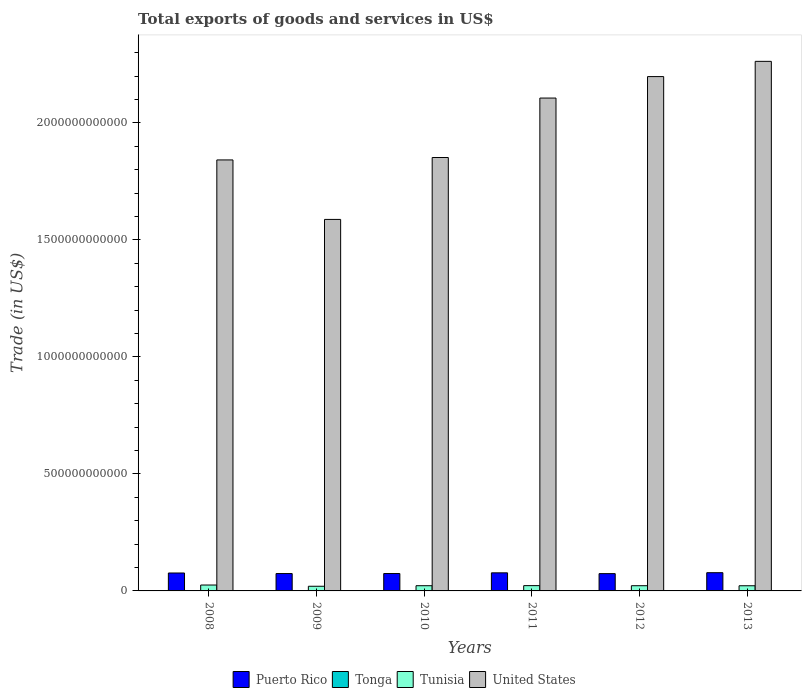Are the number of bars on each tick of the X-axis equal?
Make the answer very short. Yes. What is the label of the 1st group of bars from the left?
Offer a terse response. 2008. In how many cases, is the number of bars for a given year not equal to the number of legend labels?
Offer a very short reply. 0. What is the total exports of goods and services in Puerto Rico in 2008?
Provide a succinct answer. 7.66e+1. Across all years, what is the maximum total exports of goods and services in Tonga?
Your answer should be very brief. 9.16e+07. Across all years, what is the minimum total exports of goods and services in United States?
Offer a terse response. 1.59e+12. In which year was the total exports of goods and services in Puerto Rico maximum?
Offer a very short reply. 2013. In which year was the total exports of goods and services in Tonga minimum?
Your response must be concise. 2009. What is the total total exports of goods and services in Tunisia in the graph?
Offer a terse response. 1.34e+11. What is the difference between the total exports of goods and services in Tonga in 2008 and that in 2009?
Your answer should be compact. 7.40e+05. What is the difference between the total exports of goods and services in Puerto Rico in 2008 and the total exports of goods and services in Tunisia in 2013?
Provide a short and direct response. 5.45e+1. What is the average total exports of goods and services in Tonga per year?
Ensure brevity in your answer.  6.58e+07. In the year 2009, what is the difference between the total exports of goods and services in United States and total exports of goods and services in Tonga?
Ensure brevity in your answer.  1.59e+12. What is the ratio of the total exports of goods and services in Puerto Rico in 2008 to that in 2010?
Your response must be concise. 1.03. Is the total exports of goods and services in Puerto Rico in 2011 less than that in 2012?
Keep it short and to the point. No. What is the difference between the highest and the second highest total exports of goods and services in Puerto Rico?
Keep it short and to the point. 6.43e+08. What is the difference between the highest and the lowest total exports of goods and services in Tunisia?
Make the answer very short. 5.28e+09. In how many years, is the total exports of goods and services in Puerto Rico greater than the average total exports of goods and services in Puerto Rico taken over all years?
Provide a short and direct response. 3. Is it the case that in every year, the sum of the total exports of goods and services in Tonga and total exports of goods and services in Puerto Rico is greater than the sum of total exports of goods and services in Tunisia and total exports of goods and services in United States?
Offer a very short reply. Yes. What does the 1st bar from the left in 2012 represents?
Make the answer very short. Puerto Rico. What does the 2nd bar from the right in 2013 represents?
Give a very brief answer. Tunisia. Is it the case that in every year, the sum of the total exports of goods and services in Tunisia and total exports of goods and services in Puerto Rico is greater than the total exports of goods and services in United States?
Make the answer very short. No. What is the difference between two consecutive major ticks on the Y-axis?
Your response must be concise. 5.00e+11. Are the values on the major ticks of Y-axis written in scientific E-notation?
Ensure brevity in your answer.  No. Where does the legend appear in the graph?
Offer a very short reply. Bottom center. How many legend labels are there?
Your response must be concise. 4. What is the title of the graph?
Your response must be concise. Total exports of goods and services in US$. Does "Faeroe Islands" appear as one of the legend labels in the graph?
Make the answer very short. No. What is the label or title of the X-axis?
Offer a terse response. Years. What is the label or title of the Y-axis?
Provide a succinct answer. Trade (in US$). What is the Trade (in US$) in Puerto Rico in 2008?
Make the answer very short. 7.66e+1. What is the Trade (in US$) of Tonga in 2008?
Make the answer very short. 4.65e+07. What is the Trade (in US$) of Tunisia in 2008?
Make the answer very short. 2.52e+1. What is the Trade (in US$) of United States in 2008?
Make the answer very short. 1.84e+12. What is the Trade (in US$) of Puerto Rico in 2009?
Make the answer very short. 7.42e+1. What is the Trade (in US$) in Tonga in 2009?
Offer a terse response. 4.58e+07. What is the Trade (in US$) in Tunisia in 2009?
Offer a terse response. 1.99e+1. What is the Trade (in US$) in United States in 2009?
Provide a short and direct response. 1.59e+12. What is the Trade (in US$) of Puerto Rico in 2010?
Your answer should be compact. 7.43e+1. What is the Trade (in US$) in Tonga in 2010?
Offer a terse response. 4.72e+07. What is the Trade (in US$) of Tunisia in 2010?
Keep it short and to the point. 2.22e+1. What is the Trade (in US$) of United States in 2010?
Make the answer very short. 1.85e+12. What is the Trade (in US$) in Puerto Rico in 2011?
Make the answer very short. 7.73e+1. What is the Trade (in US$) of Tonga in 2011?
Your response must be concise. 7.43e+07. What is the Trade (in US$) in Tunisia in 2011?
Give a very brief answer. 2.26e+1. What is the Trade (in US$) in United States in 2011?
Your answer should be compact. 2.11e+12. What is the Trade (in US$) in Puerto Rico in 2012?
Offer a terse response. 7.39e+1. What is the Trade (in US$) in Tonga in 2012?
Your answer should be compact. 8.93e+07. What is the Trade (in US$) of Tunisia in 2012?
Make the answer very short. 2.23e+1. What is the Trade (in US$) of United States in 2012?
Provide a short and direct response. 2.20e+12. What is the Trade (in US$) in Puerto Rico in 2013?
Your answer should be compact. 7.79e+1. What is the Trade (in US$) in Tonga in 2013?
Your answer should be very brief. 9.16e+07. What is the Trade (in US$) of Tunisia in 2013?
Provide a succinct answer. 2.21e+1. What is the Trade (in US$) in United States in 2013?
Offer a terse response. 2.26e+12. Across all years, what is the maximum Trade (in US$) of Puerto Rico?
Your answer should be very brief. 7.79e+1. Across all years, what is the maximum Trade (in US$) of Tonga?
Your response must be concise. 9.16e+07. Across all years, what is the maximum Trade (in US$) of Tunisia?
Your answer should be very brief. 2.52e+1. Across all years, what is the maximum Trade (in US$) in United States?
Offer a very short reply. 2.26e+12. Across all years, what is the minimum Trade (in US$) of Puerto Rico?
Give a very brief answer. 7.39e+1. Across all years, what is the minimum Trade (in US$) in Tonga?
Provide a succinct answer. 4.58e+07. Across all years, what is the minimum Trade (in US$) in Tunisia?
Ensure brevity in your answer.  1.99e+1. Across all years, what is the minimum Trade (in US$) in United States?
Your answer should be very brief. 1.59e+12. What is the total Trade (in US$) in Puerto Rico in the graph?
Give a very brief answer. 4.54e+11. What is the total Trade (in US$) of Tonga in the graph?
Keep it short and to the point. 3.95e+08. What is the total Trade (in US$) of Tunisia in the graph?
Your response must be concise. 1.34e+11. What is the total Trade (in US$) of United States in the graph?
Keep it short and to the point. 1.18e+13. What is the difference between the Trade (in US$) of Puerto Rico in 2008 and that in 2009?
Keep it short and to the point. 2.40e+09. What is the difference between the Trade (in US$) of Tonga in 2008 and that in 2009?
Keep it short and to the point. 7.40e+05. What is the difference between the Trade (in US$) of Tunisia in 2008 and that in 2009?
Make the answer very short. 5.28e+09. What is the difference between the Trade (in US$) of United States in 2008 and that in 2009?
Your answer should be very brief. 2.54e+11. What is the difference between the Trade (in US$) of Puerto Rico in 2008 and that in 2010?
Ensure brevity in your answer.  2.30e+09. What is the difference between the Trade (in US$) in Tonga in 2008 and that in 2010?
Your response must be concise. -6.13e+05. What is the difference between the Trade (in US$) in Tunisia in 2008 and that in 2010?
Offer a very short reply. 2.96e+09. What is the difference between the Trade (in US$) of United States in 2008 and that in 2010?
Offer a very short reply. -1.04e+1. What is the difference between the Trade (in US$) of Puerto Rico in 2008 and that in 2011?
Ensure brevity in your answer.  -6.60e+08. What is the difference between the Trade (in US$) in Tonga in 2008 and that in 2011?
Provide a short and direct response. -2.78e+07. What is the difference between the Trade (in US$) in Tunisia in 2008 and that in 2011?
Offer a very short reply. 2.60e+09. What is the difference between the Trade (in US$) in United States in 2008 and that in 2011?
Offer a very short reply. -2.64e+11. What is the difference between the Trade (in US$) in Puerto Rico in 2008 and that in 2012?
Your answer should be very brief. 2.70e+09. What is the difference between the Trade (in US$) in Tonga in 2008 and that in 2012?
Keep it short and to the point. -4.27e+07. What is the difference between the Trade (in US$) of Tunisia in 2008 and that in 2012?
Your answer should be very brief. 2.95e+09. What is the difference between the Trade (in US$) of United States in 2008 and that in 2012?
Provide a succinct answer. -3.56e+11. What is the difference between the Trade (in US$) of Puerto Rico in 2008 and that in 2013?
Make the answer very short. -1.30e+09. What is the difference between the Trade (in US$) in Tonga in 2008 and that in 2013?
Ensure brevity in your answer.  -4.51e+07. What is the difference between the Trade (in US$) of Tunisia in 2008 and that in 2013?
Your response must be concise. 3.12e+09. What is the difference between the Trade (in US$) in United States in 2008 and that in 2013?
Your answer should be very brief. -4.21e+11. What is the difference between the Trade (in US$) in Puerto Rico in 2009 and that in 2010?
Offer a terse response. -9.71e+07. What is the difference between the Trade (in US$) in Tonga in 2009 and that in 2010?
Ensure brevity in your answer.  -1.35e+06. What is the difference between the Trade (in US$) of Tunisia in 2009 and that in 2010?
Ensure brevity in your answer.  -2.32e+09. What is the difference between the Trade (in US$) of United States in 2009 and that in 2010?
Your answer should be very brief. -2.65e+11. What is the difference between the Trade (in US$) in Puerto Rico in 2009 and that in 2011?
Offer a terse response. -3.06e+09. What is the difference between the Trade (in US$) in Tonga in 2009 and that in 2011?
Your answer should be compact. -2.85e+07. What is the difference between the Trade (in US$) in Tunisia in 2009 and that in 2011?
Provide a succinct answer. -2.69e+09. What is the difference between the Trade (in US$) of United States in 2009 and that in 2011?
Keep it short and to the point. -5.19e+11. What is the difference between the Trade (in US$) of Puerto Rico in 2009 and that in 2012?
Your response must be concise. 3.04e+08. What is the difference between the Trade (in US$) of Tonga in 2009 and that in 2012?
Provide a succinct answer. -4.35e+07. What is the difference between the Trade (in US$) of Tunisia in 2009 and that in 2012?
Your answer should be compact. -2.33e+09. What is the difference between the Trade (in US$) in United States in 2009 and that in 2012?
Make the answer very short. -6.10e+11. What is the difference between the Trade (in US$) in Puerto Rico in 2009 and that in 2013?
Give a very brief answer. -3.70e+09. What is the difference between the Trade (in US$) of Tonga in 2009 and that in 2013?
Provide a short and direct response. -4.58e+07. What is the difference between the Trade (in US$) of Tunisia in 2009 and that in 2013?
Ensure brevity in your answer.  -2.17e+09. What is the difference between the Trade (in US$) in United States in 2009 and that in 2013?
Offer a very short reply. -6.76e+11. What is the difference between the Trade (in US$) of Puerto Rico in 2010 and that in 2011?
Keep it short and to the point. -2.96e+09. What is the difference between the Trade (in US$) in Tonga in 2010 and that in 2011?
Offer a terse response. -2.72e+07. What is the difference between the Trade (in US$) in Tunisia in 2010 and that in 2011?
Your answer should be very brief. -3.66e+08. What is the difference between the Trade (in US$) of United States in 2010 and that in 2011?
Ensure brevity in your answer.  -2.54e+11. What is the difference between the Trade (in US$) of Puerto Rico in 2010 and that in 2012?
Your answer should be very brief. 4.01e+08. What is the difference between the Trade (in US$) in Tonga in 2010 and that in 2012?
Provide a succinct answer. -4.21e+07. What is the difference between the Trade (in US$) of Tunisia in 2010 and that in 2012?
Provide a succinct answer. -1.40e+07. What is the difference between the Trade (in US$) of United States in 2010 and that in 2012?
Ensure brevity in your answer.  -3.46e+11. What is the difference between the Trade (in US$) of Puerto Rico in 2010 and that in 2013?
Make the answer very short. -3.61e+09. What is the difference between the Trade (in US$) in Tonga in 2010 and that in 2013?
Make the answer very short. -4.45e+07. What is the difference between the Trade (in US$) of Tunisia in 2010 and that in 2013?
Ensure brevity in your answer.  1.54e+08. What is the difference between the Trade (in US$) of United States in 2010 and that in 2013?
Your answer should be very brief. -4.11e+11. What is the difference between the Trade (in US$) of Puerto Rico in 2011 and that in 2012?
Your answer should be compact. 3.36e+09. What is the difference between the Trade (in US$) in Tonga in 2011 and that in 2012?
Provide a succinct answer. -1.49e+07. What is the difference between the Trade (in US$) of Tunisia in 2011 and that in 2012?
Make the answer very short. 3.52e+08. What is the difference between the Trade (in US$) of United States in 2011 and that in 2012?
Ensure brevity in your answer.  -9.18e+1. What is the difference between the Trade (in US$) of Puerto Rico in 2011 and that in 2013?
Make the answer very short. -6.43e+08. What is the difference between the Trade (in US$) of Tonga in 2011 and that in 2013?
Your answer should be very brief. -1.73e+07. What is the difference between the Trade (in US$) in Tunisia in 2011 and that in 2013?
Provide a succinct answer. 5.20e+08. What is the difference between the Trade (in US$) of United States in 2011 and that in 2013?
Offer a very short reply. -1.57e+11. What is the difference between the Trade (in US$) in Puerto Rico in 2012 and that in 2013?
Give a very brief answer. -4.01e+09. What is the difference between the Trade (in US$) in Tonga in 2012 and that in 2013?
Provide a short and direct response. -2.35e+06. What is the difference between the Trade (in US$) in Tunisia in 2012 and that in 2013?
Offer a very short reply. 1.68e+08. What is the difference between the Trade (in US$) in United States in 2012 and that in 2013?
Your answer should be very brief. -6.51e+1. What is the difference between the Trade (in US$) of Puerto Rico in 2008 and the Trade (in US$) of Tonga in 2009?
Keep it short and to the point. 7.66e+1. What is the difference between the Trade (in US$) in Puerto Rico in 2008 and the Trade (in US$) in Tunisia in 2009?
Offer a terse response. 5.67e+1. What is the difference between the Trade (in US$) in Puerto Rico in 2008 and the Trade (in US$) in United States in 2009?
Make the answer very short. -1.51e+12. What is the difference between the Trade (in US$) in Tonga in 2008 and the Trade (in US$) in Tunisia in 2009?
Offer a very short reply. -1.99e+1. What is the difference between the Trade (in US$) of Tonga in 2008 and the Trade (in US$) of United States in 2009?
Ensure brevity in your answer.  -1.59e+12. What is the difference between the Trade (in US$) of Tunisia in 2008 and the Trade (in US$) of United States in 2009?
Provide a short and direct response. -1.56e+12. What is the difference between the Trade (in US$) in Puerto Rico in 2008 and the Trade (in US$) in Tonga in 2010?
Give a very brief answer. 7.66e+1. What is the difference between the Trade (in US$) of Puerto Rico in 2008 and the Trade (in US$) of Tunisia in 2010?
Make the answer very short. 5.44e+1. What is the difference between the Trade (in US$) of Puerto Rico in 2008 and the Trade (in US$) of United States in 2010?
Your answer should be compact. -1.78e+12. What is the difference between the Trade (in US$) in Tonga in 2008 and the Trade (in US$) in Tunisia in 2010?
Provide a succinct answer. -2.22e+1. What is the difference between the Trade (in US$) of Tonga in 2008 and the Trade (in US$) of United States in 2010?
Offer a terse response. -1.85e+12. What is the difference between the Trade (in US$) in Tunisia in 2008 and the Trade (in US$) in United States in 2010?
Your response must be concise. -1.83e+12. What is the difference between the Trade (in US$) of Puerto Rico in 2008 and the Trade (in US$) of Tonga in 2011?
Offer a terse response. 7.65e+1. What is the difference between the Trade (in US$) in Puerto Rico in 2008 and the Trade (in US$) in Tunisia in 2011?
Your answer should be compact. 5.40e+1. What is the difference between the Trade (in US$) of Puerto Rico in 2008 and the Trade (in US$) of United States in 2011?
Give a very brief answer. -2.03e+12. What is the difference between the Trade (in US$) of Tonga in 2008 and the Trade (in US$) of Tunisia in 2011?
Offer a very short reply. -2.26e+1. What is the difference between the Trade (in US$) in Tonga in 2008 and the Trade (in US$) in United States in 2011?
Give a very brief answer. -2.11e+12. What is the difference between the Trade (in US$) of Tunisia in 2008 and the Trade (in US$) of United States in 2011?
Make the answer very short. -2.08e+12. What is the difference between the Trade (in US$) in Puerto Rico in 2008 and the Trade (in US$) in Tonga in 2012?
Give a very brief answer. 7.65e+1. What is the difference between the Trade (in US$) of Puerto Rico in 2008 and the Trade (in US$) of Tunisia in 2012?
Offer a terse response. 5.44e+1. What is the difference between the Trade (in US$) in Puerto Rico in 2008 and the Trade (in US$) in United States in 2012?
Give a very brief answer. -2.12e+12. What is the difference between the Trade (in US$) of Tonga in 2008 and the Trade (in US$) of Tunisia in 2012?
Keep it short and to the point. -2.22e+1. What is the difference between the Trade (in US$) of Tonga in 2008 and the Trade (in US$) of United States in 2012?
Your answer should be very brief. -2.20e+12. What is the difference between the Trade (in US$) of Tunisia in 2008 and the Trade (in US$) of United States in 2012?
Ensure brevity in your answer.  -2.17e+12. What is the difference between the Trade (in US$) of Puerto Rico in 2008 and the Trade (in US$) of Tonga in 2013?
Offer a very short reply. 7.65e+1. What is the difference between the Trade (in US$) in Puerto Rico in 2008 and the Trade (in US$) in Tunisia in 2013?
Make the answer very short. 5.45e+1. What is the difference between the Trade (in US$) in Puerto Rico in 2008 and the Trade (in US$) in United States in 2013?
Make the answer very short. -2.19e+12. What is the difference between the Trade (in US$) in Tonga in 2008 and the Trade (in US$) in Tunisia in 2013?
Provide a succinct answer. -2.20e+1. What is the difference between the Trade (in US$) of Tonga in 2008 and the Trade (in US$) of United States in 2013?
Offer a very short reply. -2.26e+12. What is the difference between the Trade (in US$) in Tunisia in 2008 and the Trade (in US$) in United States in 2013?
Offer a very short reply. -2.24e+12. What is the difference between the Trade (in US$) in Puerto Rico in 2009 and the Trade (in US$) in Tonga in 2010?
Your answer should be compact. 7.42e+1. What is the difference between the Trade (in US$) in Puerto Rico in 2009 and the Trade (in US$) in Tunisia in 2010?
Your answer should be compact. 5.20e+1. What is the difference between the Trade (in US$) in Puerto Rico in 2009 and the Trade (in US$) in United States in 2010?
Provide a short and direct response. -1.78e+12. What is the difference between the Trade (in US$) in Tonga in 2009 and the Trade (in US$) in Tunisia in 2010?
Offer a very short reply. -2.22e+1. What is the difference between the Trade (in US$) of Tonga in 2009 and the Trade (in US$) of United States in 2010?
Ensure brevity in your answer.  -1.85e+12. What is the difference between the Trade (in US$) of Tunisia in 2009 and the Trade (in US$) of United States in 2010?
Provide a succinct answer. -1.83e+12. What is the difference between the Trade (in US$) of Puerto Rico in 2009 and the Trade (in US$) of Tonga in 2011?
Offer a terse response. 7.41e+1. What is the difference between the Trade (in US$) in Puerto Rico in 2009 and the Trade (in US$) in Tunisia in 2011?
Give a very brief answer. 5.16e+1. What is the difference between the Trade (in US$) of Puerto Rico in 2009 and the Trade (in US$) of United States in 2011?
Your answer should be very brief. -2.03e+12. What is the difference between the Trade (in US$) in Tonga in 2009 and the Trade (in US$) in Tunisia in 2011?
Ensure brevity in your answer.  -2.26e+1. What is the difference between the Trade (in US$) of Tonga in 2009 and the Trade (in US$) of United States in 2011?
Offer a very short reply. -2.11e+12. What is the difference between the Trade (in US$) in Tunisia in 2009 and the Trade (in US$) in United States in 2011?
Offer a terse response. -2.09e+12. What is the difference between the Trade (in US$) of Puerto Rico in 2009 and the Trade (in US$) of Tonga in 2012?
Provide a succinct answer. 7.41e+1. What is the difference between the Trade (in US$) of Puerto Rico in 2009 and the Trade (in US$) of Tunisia in 2012?
Ensure brevity in your answer.  5.20e+1. What is the difference between the Trade (in US$) of Puerto Rico in 2009 and the Trade (in US$) of United States in 2012?
Give a very brief answer. -2.12e+12. What is the difference between the Trade (in US$) in Tonga in 2009 and the Trade (in US$) in Tunisia in 2012?
Your answer should be compact. -2.22e+1. What is the difference between the Trade (in US$) of Tonga in 2009 and the Trade (in US$) of United States in 2012?
Provide a succinct answer. -2.20e+12. What is the difference between the Trade (in US$) of Tunisia in 2009 and the Trade (in US$) of United States in 2012?
Your answer should be very brief. -2.18e+12. What is the difference between the Trade (in US$) of Puerto Rico in 2009 and the Trade (in US$) of Tonga in 2013?
Offer a very short reply. 7.41e+1. What is the difference between the Trade (in US$) in Puerto Rico in 2009 and the Trade (in US$) in Tunisia in 2013?
Your answer should be compact. 5.21e+1. What is the difference between the Trade (in US$) in Puerto Rico in 2009 and the Trade (in US$) in United States in 2013?
Provide a short and direct response. -2.19e+12. What is the difference between the Trade (in US$) of Tonga in 2009 and the Trade (in US$) of Tunisia in 2013?
Provide a short and direct response. -2.20e+1. What is the difference between the Trade (in US$) of Tonga in 2009 and the Trade (in US$) of United States in 2013?
Offer a terse response. -2.26e+12. What is the difference between the Trade (in US$) in Tunisia in 2009 and the Trade (in US$) in United States in 2013?
Your response must be concise. -2.24e+12. What is the difference between the Trade (in US$) of Puerto Rico in 2010 and the Trade (in US$) of Tonga in 2011?
Provide a short and direct response. 7.42e+1. What is the difference between the Trade (in US$) in Puerto Rico in 2010 and the Trade (in US$) in Tunisia in 2011?
Make the answer very short. 5.17e+1. What is the difference between the Trade (in US$) in Puerto Rico in 2010 and the Trade (in US$) in United States in 2011?
Your answer should be compact. -2.03e+12. What is the difference between the Trade (in US$) of Tonga in 2010 and the Trade (in US$) of Tunisia in 2011?
Give a very brief answer. -2.26e+1. What is the difference between the Trade (in US$) of Tonga in 2010 and the Trade (in US$) of United States in 2011?
Your response must be concise. -2.11e+12. What is the difference between the Trade (in US$) of Tunisia in 2010 and the Trade (in US$) of United States in 2011?
Provide a short and direct response. -2.08e+12. What is the difference between the Trade (in US$) of Puerto Rico in 2010 and the Trade (in US$) of Tonga in 2012?
Your response must be concise. 7.42e+1. What is the difference between the Trade (in US$) in Puerto Rico in 2010 and the Trade (in US$) in Tunisia in 2012?
Your answer should be very brief. 5.21e+1. What is the difference between the Trade (in US$) in Puerto Rico in 2010 and the Trade (in US$) in United States in 2012?
Your answer should be compact. -2.12e+12. What is the difference between the Trade (in US$) in Tonga in 2010 and the Trade (in US$) in Tunisia in 2012?
Make the answer very short. -2.22e+1. What is the difference between the Trade (in US$) in Tonga in 2010 and the Trade (in US$) in United States in 2012?
Provide a succinct answer. -2.20e+12. What is the difference between the Trade (in US$) of Tunisia in 2010 and the Trade (in US$) of United States in 2012?
Keep it short and to the point. -2.18e+12. What is the difference between the Trade (in US$) of Puerto Rico in 2010 and the Trade (in US$) of Tonga in 2013?
Keep it short and to the point. 7.42e+1. What is the difference between the Trade (in US$) in Puerto Rico in 2010 and the Trade (in US$) in Tunisia in 2013?
Give a very brief answer. 5.22e+1. What is the difference between the Trade (in US$) of Puerto Rico in 2010 and the Trade (in US$) of United States in 2013?
Provide a short and direct response. -2.19e+12. What is the difference between the Trade (in US$) in Tonga in 2010 and the Trade (in US$) in Tunisia in 2013?
Offer a very short reply. -2.20e+1. What is the difference between the Trade (in US$) of Tonga in 2010 and the Trade (in US$) of United States in 2013?
Your response must be concise. -2.26e+12. What is the difference between the Trade (in US$) in Tunisia in 2010 and the Trade (in US$) in United States in 2013?
Your answer should be compact. -2.24e+12. What is the difference between the Trade (in US$) in Puerto Rico in 2011 and the Trade (in US$) in Tonga in 2012?
Make the answer very short. 7.72e+1. What is the difference between the Trade (in US$) in Puerto Rico in 2011 and the Trade (in US$) in Tunisia in 2012?
Ensure brevity in your answer.  5.50e+1. What is the difference between the Trade (in US$) in Puerto Rico in 2011 and the Trade (in US$) in United States in 2012?
Provide a short and direct response. -2.12e+12. What is the difference between the Trade (in US$) of Tonga in 2011 and the Trade (in US$) of Tunisia in 2012?
Give a very brief answer. -2.22e+1. What is the difference between the Trade (in US$) in Tonga in 2011 and the Trade (in US$) in United States in 2012?
Offer a terse response. -2.20e+12. What is the difference between the Trade (in US$) of Tunisia in 2011 and the Trade (in US$) of United States in 2012?
Provide a short and direct response. -2.18e+12. What is the difference between the Trade (in US$) of Puerto Rico in 2011 and the Trade (in US$) of Tonga in 2013?
Your answer should be compact. 7.72e+1. What is the difference between the Trade (in US$) of Puerto Rico in 2011 and the Trade (in US$) of Tunisia in 2013?
Offer a terse response. 5.52e+1. What is the difference between the Trade (in US$) of Puerto Rico in 2011 and the Trade (in US$) of United States in 2013?
Keep it short and to the point. -2.19e+12. What is the difference between the Trade (in US$) in Tonga in 2011 and the Trade (in US$) in Tunisia in 2013?
Your response must be concise. -2.20e+1. What is the difference between the Trade (in US$) of Tonga in 2011 and the Trade (in US$) of United States in 2013?
Ensure brevity in your answer.  -2.26e+12. What is the difference between the Trade (in US$) of Tunisia in 2011 and the Trade (in US$) of United States in 2013?
Give a very brief answer. -2.24e+12. What is the difference between the Trade (in US$) in Puerto Rico in 2012 and the Trade (in US$) in Tonga in 2013?
Provide a short and direct response. 7.38e+1. What is the difference between the Trade (in US$) in Puerto Rico in 2012 and the Trade (in US$) in Tunisia in 2013?
Offer a terse response. 5.18e+1. What is the difference between the Trade (in US$) in Puerto Rico in 2012 and the Trade (in US$) in United States in 2013?
Make the answer very short. -2.19e+12. What is the difference between the Trade (in US$) of Tonga in 2012 and the Trade (in US$) of Tunisia in 2013?
Make the answer very short. -2.20e+1. What is the difference between the Trade (in US$) in Tonga in 2012 and the Trade (in US$) in United States in 2013?
Provide a short and direct response. -2.26e+12. What is the difference between the Trade (in US$) in Tunisia in 2012 and the Trade (in US$) in United States in 2013?
Provide a short and direct response. -2.24e+12. What is the average Trade (in US$) of Puerto Rico per year?
Keep it short and to the point. 7.57e+1. What is the average Trade (in US$) of Tonga per year?
Keep it short and to the point. 6.58e+07. What is the average Trade (in US$) in Tunisia per year?
Provide a succinct answer. 2.24e+1. What is the average Trade (in US$) of United States per year?
Ensure brevity in your answer.  1.97e+12. In the year 2008, what is the difference between the Trade (in US$) in Puerto Rico and Trade (in US$) in Tonga?
Offer a very short reply. 7.66e+1. In the year 2008, what is the difference between the Trade (in US$) in Puerto Rico and Trade (in US$) in Tunisia?
Provide a short and direct response. 5.14e+1. In the year 2008, what is the difference between the Trade (in US$) of Puerto Rico and Trade (in US$) of United States?
Provide a succinct answer. -1.77e+12. In the year 2008, what is the difference between the Trade (in US$) in Tonga and Trade (in US$) in Tunisia?
Your response must be concise. -2.52e+1. In the year 2008, what is the difference between the Trade (in US$) of Tonga and Trade (in US$) of United States?
Give a very brief answer. -1.84e+12. In the year 2008, what is the difference between the Trade (in US$) in Tunisia and Trade (in US$) in United States?
Provide a short and direct response. -1.82e+12. In the year 2009, what is the difference between the Trade (in US$) in Puerto Rico and Trade (in US$) in Tonga?
Your answer should be compact. 7.42e+1. In the year 2009, what is the difference between the Trade (in US$) of Puerto Rico and Trade (in US$) of Tunisia?
Ensure brevity in your answer.  5.43e+1. In the year 2009, what is the difference between the Trade (in US$) in Puerto Rico and Trade (in US$) in United States?
Your answer should be very brief. -1.51e+12. In the year 2009, what is the difference between the Trade (in US$) in Tonga and Trade (in US$) in Tunisia?
Make the answer very short. -1.99e+1. In the year 2009, what is the difference between the Trade (in US$) of Tonga and Trade (in US$) of United States?
Your response must be concise. -1.59e+12. In the year 2009, what is the difference between the Trade (in US$) of Tunisia and Trade (in US$) of United States?
Provide a succinct answer. -1.57e+12. In the year 2010, what is the difference between the Trade (in US$) of Puerto Rico and Trade (in US$) of Tonga?
Your answer should be very brief. 7.43e+1. In the year 2010, what is the difference between the Trade (in US$) in Puerto Rico and Trade (in US$) in Tunisia?
Your response must be concise. 5.21e+1. In the year 2010, what is the difference between the Trade (in US$) of Puerto Rico and Trade (in US$) of United States?
Offer a terse response. -1.78e+12. In the year 2010, what is the difference between the Trade (in US$) of Tonga and Trade (in US$) of Tunisia?
Your response must be concise. -2.22e+1. In the year 2010, what is the difference between the Trade (in US$) of Tonga and Trade (in US$) of United States?
Keep it short and to the point. -1.85e+12. In the year 2010, what is the difference between the Trade (in US$) in Tunisia and Trade (in US$) in United States?
Your answer should be compact. -1.83e+12. In the year 2011, what is the difference between the Trade (in US$) in Puerto Rico and Trade (in US$) in Tonga?
Ensure brevity in your answer.  7.72e+1. In the year 2011, what is the difference between the Trade (in US$) of Puerto Rico and Trade (in US$) of Tunisia?
Offer a very short reply. 5.47e+1. In the year 2011, what is the difference between the Trade (in US$) in Puerto Rico and Trade (in US$) in United States?
Make the answer very short. -2.03e+12. In the year 2011, what is the difference between the Trade (in US$) in Tonga and Trade (in US$) in Tunisia?
Your response must be concise. -2.25e+1. In the year 2011, what is the difference between the Trade (in US$) of Tonga and Trade (in US$) of United States?
Keep it short and to the point. -2.11e+12. In the year 2011, what is the difference between the Trade (in US$) of Tunisia and Trade (in US$) of United States?
Give a very brief answer. -2.08e+12. In the year 2012, what is the difference between the Trade (in US$) in Puerto Rico and Trade (in US$) in Tonga?
Offer a very short reply. 7.38e+1. In the year 2012, what is the difference between the Trade (in US$) in Puerto Rico and Trade (in US$) in Tunisia?
Give a very brief answer. 5.17e+1. In the year 2012, what is the difference between the Trade (in US$) of Puerto Rico and Trade (in US$) of United States?
Ensure brevity in your answer.  -2.12e+12. In the year 2012, what is the difference between the Trade (in US$) of Tonga and Trade (in US$) of Tunisia?
Make the answer very short. -2.22e+1. In the year 2012, what is the difference between the Trade (in US$) in Tonga and Trade (in US$) in United States?
Offer a terse response. -2.20e+12. In the year 2012, what is the difference between the Trade (in US$) of Tunisia and Trade (in US$) of United States?
Offer a terse response. -2.18e+12. In the year 2013, what is the difference between the Trade (in US$) in Puerto Rico and Trade (in US$) in Tonga?
Keep it short and to the point. 7.78e+1. In the year 2013, what is the difference between the Trade (in US$) of Puerto Rico and Trade (in US$) of Tunisia?
Your response must be concise. 5.58e+1. In the year 2013, what is the difference between the Trade (in US$) of Puerto Rico and Trade (in US$) of United States?
Give a very brief answer. -2.19e+12. In the year 2013, what is the difference between the Trade (in US$) of Tonga and Trade (in US$) of Tunisia?
Your answer should be very brief. -2.20e+1. In the year 2013, what is the difference between the Trade (in US$) in Tonga and Trade (in US$) in United States?
Your answer should be very brief. -2.26e+12. In the year 2013, what is the difference between the Trade (in US$) in Tunisia and Trade (in US$) in United States?
Your response must be concise. -2.24e+12. What is the ratio of the Trade (in US$) in Puerto Rico in 2008 to that in 2009?
Your response must be concise. 1.03. What is the ratio of the Trade (in US$) of Tonga in 2008 to that in 2009?
Your answer should be compact. 1.02. What is the ratio of the Trade (in US$) of Tunisia in 2008 to that in 2009?
Your response must be concise. 1.27. What is the ratio of the Trade (in US$) in United States in 2008 to that in 2009?
Provide a succinct answer. 1.16. What is the ratio of the Trade (in US$) of Puerto Rico in 2008 to that in 2010?
Your answer should be very brief. 1.03. What is the ratio of the Trade (in US$) of Tunisia in 2008 to that in 2010?
Ensure brevity in your answer.  1.13. What is the ratio of the Trade (in US$) of Puerto Rico in 2008 to that in 2011?
Provide a succinct answer. 0.99. What is the ratio of the Trade (in US$) in Tonga in 2008 to that in 2011?
Provide a succinct answer. 0.63. What is the ratio of the Trade (in US$) in Tunisia in 2008 to that in 2011?
Give a very brief answer. 1.11. What is the ratio of the Trade (in US$) in United States in 2008 to that in 2011?
Your response must be concise. 0.87. What is the ratio of the Trade (in US$) in Puerto Rico in 2008 to that in 2012?
Provide a short and direct response. 1.04. What is the ratio of the Trade (in US$) in Tonga in 2008 to that in 2012?
Provide a short and direct response. 0.52. What is the ratio of the Trade (in US$) in Tunisia in 2008 to that in 2012?
Your response must be concise. 1.13. What is the ratio of the Trade (in US$) in United States in 2008 to that in 2012?
Provide a short and direct response. 0.84. What is the ratio of the Trade (in US$) in Puerto Rico in 2008 to that in 2013?
Offer a very short reply. 0.98. What is the ratio of the Trade (in US$) of Tonga in 2008 to that in 2013?
Offer a very short reply. 0.51. What is the ratio of the Trade (in US$) of Tunisia in 2008 to that in 2013?
Provide a short and direct response. 1.14. What is the ratio of the Trade (in US$) of United States in 2008 to that in 2013?
Ensure brevity in your answer.  0.81. What is the ratio of the Trade (in US$) in Puerto Rico in 2009 to that in 2010?
Offer a terse response. 1. What is the ratio of the Trade (in US$) of Tonga in 2009 to that in 2010?
Provide a short and direct response. 0.97. What is the ratio of the Trade (in US$) in Tunisia in 2009 to that in 2010?
Keep it short and to the point. 0.9. What is the ratio of the Trade (in US$) of United States in 2009 to that in 2010?
Provide a short and direct response. 0.86. What is the ratio of the Trade (in US$) in Puerto Rico in 2009 to that in 2011?
Provide a short and direct response. 0.96. What is the ratio of the Trade (in US$) in Tonga in 2009 to that in 2011?
Make the answer very short. 0.62. What is the ratio of the Trade (in US$) of Tunisia in 2009 to that in 2011?
Ensure brevity in your answer.  0.88. What is the ratio of the Trade (in US$) of United States in 2009 to that in 2011?
Ensure brevity in your answer.  0.75. What is the ratio of the Trade (in US$) of Puerto Rico in 2009 to that in 2012?
Provide a succinct answer. 1. What is the ratio of the Trade (in US$) in Tonga in 2009 to that in 2012?
Offer a very short reply. 0.51. What is the ratio of the Trade (in US$) of Tunisia in 2009 to that in 2012?
Offer a very short reply. 0.9. What is the ratio of the Trade (in US$) in United States in 2009 to that in 2012?
Provide a short and direct response. 0.72. What is the ratio of the Trade (in US$) in Puerto Rico in 2009 to that in 2013?
Ensure brevity in your answer.  0.95. What is the ratio of the Trade (in US$) in Tonga in 2009 to that in 2013?
Make the answer very short. 0.5. What is the ratio of the Trade (in US$) in Tunisia in 2009 to that in 2013?
Provide a succinct answer. 0.9. What is the ratio of the Trade (in US$) of United States in 2009 to that in 2013?
Your response must be concise. 0.7. What is the ratio of the Trade (in US$) in Puerto Rico in 2010 to that in 2011?
Provide a short and direct response. 0.96. What is the ratio of the Trade (in US$) in Tonga in 2010 to that in 2011?
Offer a very short reply. 0.63. What is the ratio of the Trade (in US$) in Tunisia in 2010 to that in 2011?
Offer a terse response. 0.98. What is the ratio of the Trade (in US$) in United States in 2010 to that in 2011?
Keep it short and to the point. 0.88. What is the ratio of the Trade (in US$) of Puerto Rico in 2010 to that in 2012?
Keep it short and to the point. 1.01. What is the ratio of the Trade (in US$) of Tonga in 2010 to that in 2012?
Ensure brevity in your answer.  0.53. What is the ratio of the Trade (in US$) in United States in 2010 to that in 2012?
Your response must be concise. 0.84. What is the ratio of the Trade (in US$) of Puerto Rico in 2010 to that in 2013?
Keep it short and to the point. 0.95. What is the ratio of the Trade (in US$) of Tonga in 2010 to that in 2013?
Offer a very short reply. 0.51. What is the ratio of the Trade (in US$) of Tunisia in 2010 to that in 2013?
Offer a terse response. 1.01. What is the ratio of the Trade (in US$) in United States in 2010 to that in 2013?
Your answer should be very brief. 0.82. What is the ratio of the Trade (in US$) in Puerto Rico in 2011 to that in 2012?
Provide a succinct answer. 1.05. What is the ratio of the Trade (in US$) in Tonga in 2011 to that in 2012?
Ensure brevity in your answer.  0.83. What is the ratio of the Trade (in US$) in Tunisia in 2011 to that in 2012?
Provide a short and direct response. 1.02. What is the ratio of the Trade (in US$) in United States in 2011 to that in 2012?
Offer a very short reply. 0.96. What is the ratio of the Trade (in US$) in Puerto Rico in 2011 to that in 2013?
Your answer should be very brief. 0.99. What is the ratio of the Trade (in US$) in Tonga in 2011 to that in 2013?
Ensure brevity in your answer.  0.81. What is the ratio of the Trade (in US$) in Tunisia in 2011 to that in 2013?
Offer a terse response. 1.02. What is the ratio of the Trade (in US$) in United States in 2011 to that in 2013?
Give a very brief answer. 0.93. What is the ratio of the Trade (in US$) in Puerto Rico in 2012 to that in 2013?
Ensure brevity in your answer.  0.95. What is the ratio of the Trade (in US$) in Tonga in 2012 to that in 2013?
Provide a succinct answer. 0.97. What is the ratio of the Trade (in US$) in Tunisia in 2012 to that in 2013?
Make the answer very short. 1.01. What is the ratio of the Trade (in US$) in United States in 2012 to that in 2013?
Keep it short and to the point. 0.97. What is the difference between the highest and the second highest Trade (in US$) of Puerto Rico?
Your answer should be compact. 6.43e+08. What is the difference between the highest and the second highest Trade (in US$) of Tonga?
Your answer should be very brief. 2.35e+06. What is the difference between the highest and the second highest Trade (in US$) in Tunisia?
Your answer should be very brief. 2.60e+09. What is the difference between the highest and the second highest Trade (in US$) in United States?
Provide a short and direct response. 6.51e+1. What is the difference between the highest and the lowest Trade (in US$) in Puerto Rico?
Keep it short and to the point. 4.01e+09. What is the difference between the highest and the lowest Trade (in US$) of Tonga?
Your response must be concise. 4.58e+07. What is the difference between the highest and the lowest Trade (in US$) of Tunisia?
Offer a very short reply. 5.28e+09. What is the difference between the highest and the lowest Trade (in US$) of United States?
Your response must be concise. 6.76e+11. 